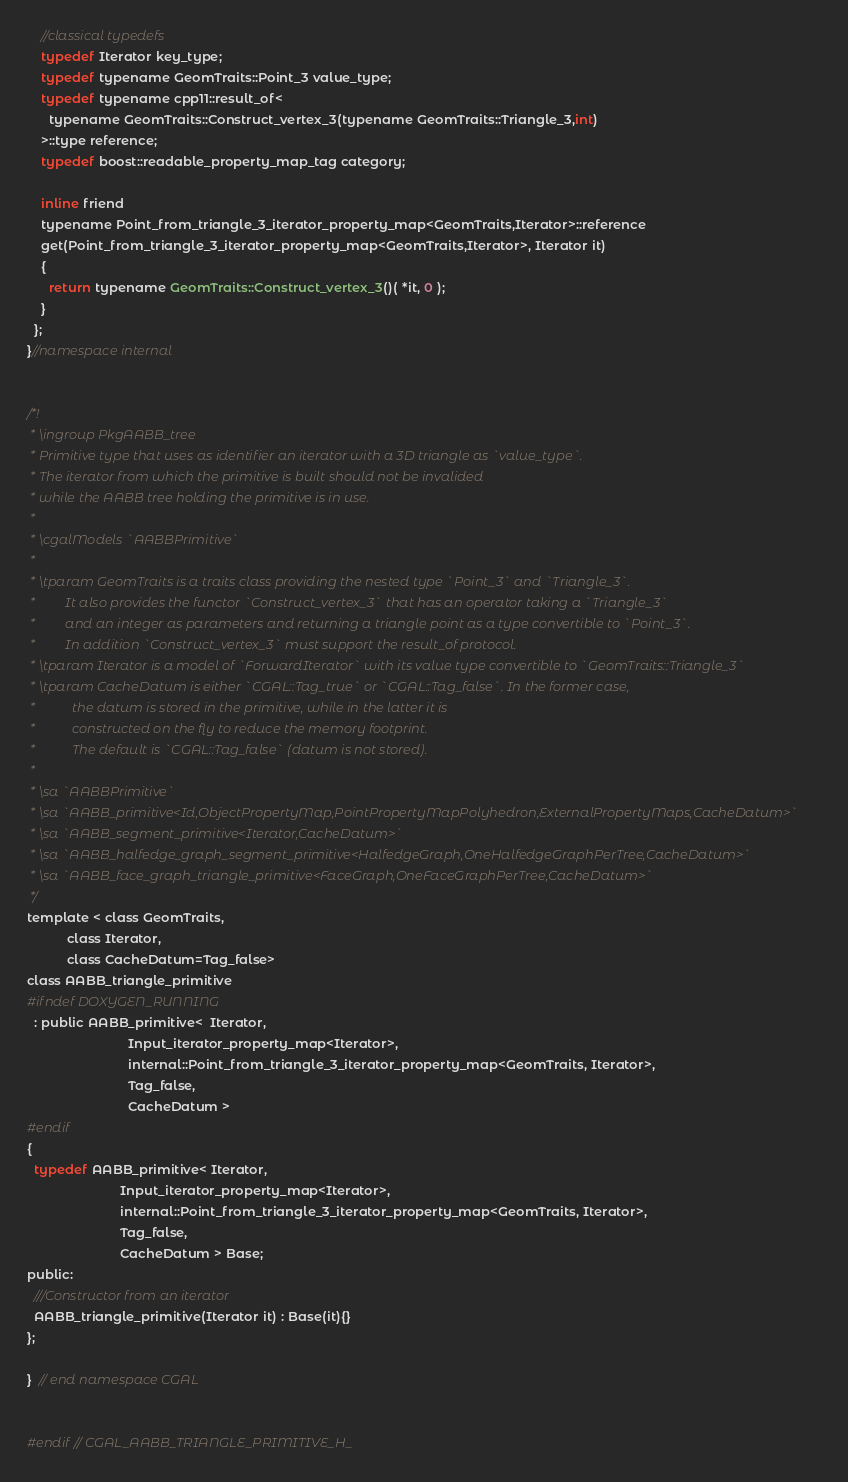Convert code to text. <code><loc_0><loc_0><loc_500><loc_500><_C_>    //classical typedefs
    typedef Iterator key_type;
    typedef typename GeomTraits::Point_3 value_type;
    typedef typename cpp11::result_of<
      typename GeomTraits::Construct_vertex_3(typename GeomTraits::Triangle_3,int)
    >::type reference;
    typedef boost::readable_property_map_tag category;

    inline friend
    typename Point_from_triangle_3_iterator_property_map<GeomTraits,Iterator>::reference
    get(Point_from_triangle_3_iterator_property_map<GeomTraits,Iterator>, Iterator it)
    {
      return typename GeomTraits::Construct_vertex_3()( *it, 0 );
    }
  };
}//namespace internal


/*!
 * \ingroup PkgAABB_tree
 * Primitive type that uses as identifier an iterator with a 3D triangle as `value_type`.
 * The iterator from which the primitive is built should not be invalided
 * while the AABB tree holding the primitive is in use.
 *
 * \cgalModels `AABBPrimitive`
 *
 * \tparam GeomTraits is a traits class providing the nested type `Point_3` and `Triangle_3`.
 *         It also provides the functor `Construct_vertex_3` that has an operator taking a `Triangle_3`
 *         and an integer as parameters and returning a triangle point as a type convertible to `Point_3`.
 *         In addition `Construct_vertex_3` must support the result_of protocol.
 * \tparam Iterator is a model of `ForwardIterator` with its value type convertible to `GeomTraits::Triangle_3`
 * \tparam CacheDatum is either `CGAL::Tag_true` or `CGAL::Tag_false`. In the former case,
 *           the datum is stored in the primitive, while in the latter it is
 *           constructed on the fly to reduce the memory footprint.
 *           The default is `CGAL::Tag_false` (datum is not stored).
 *
 * \sa `AABBPrimitive`
 * \sa `AABB_primitive<Id,ObjectPropertyMap,PointPropertyMapPolyhedron,ExternalPropertyMaps,CacheDatum>`
 * \sa `AABB_segment_primitive<Iterator,CacheDatum>`
 * \sa `AABB_halfedge_graph_segment_primitive<HalfedgeGraph,OneHalfedgeGraphPerTree,CacheDatum>`
 * \sa `AABB_face_graph_triangle_primitive<FaceGraph,OneFaceGraphPerTree,CacheDatum>`
 */
template < class GeomTraits,
           class Iterator,
           class CacheDatum=Tag_false>
class AABB_triangle_primitive
#ifndef DOXYGEN_RUNNING
  : public AABB_primitive<  Iterator,
                            Input_iterator_property_map<Iterator>,
                            internal::Point_from_triangle_3_iterator_property_map<GeomTraits, Iterator>,
                            Tag_false,
                            CacheDatum >
#endif
{
  typedef AABB_primitive< Iterator,
                          Input_iterator_property_map<Iterator>,
                          internal::Point_from_triangle_3_iterator_property_map<GeomTraits, Iterator>,
                          Tag_false,
                          CacheDatum > Base;
public:
  ///Constructor from an iterator
  AABB_triangle_primitive(Iterator it) : Base(it){}
};

}  // end namespace CGAL


#endif // CGAL_AABB_TRIANGLE_PRIMITIVE_H_

</code> 